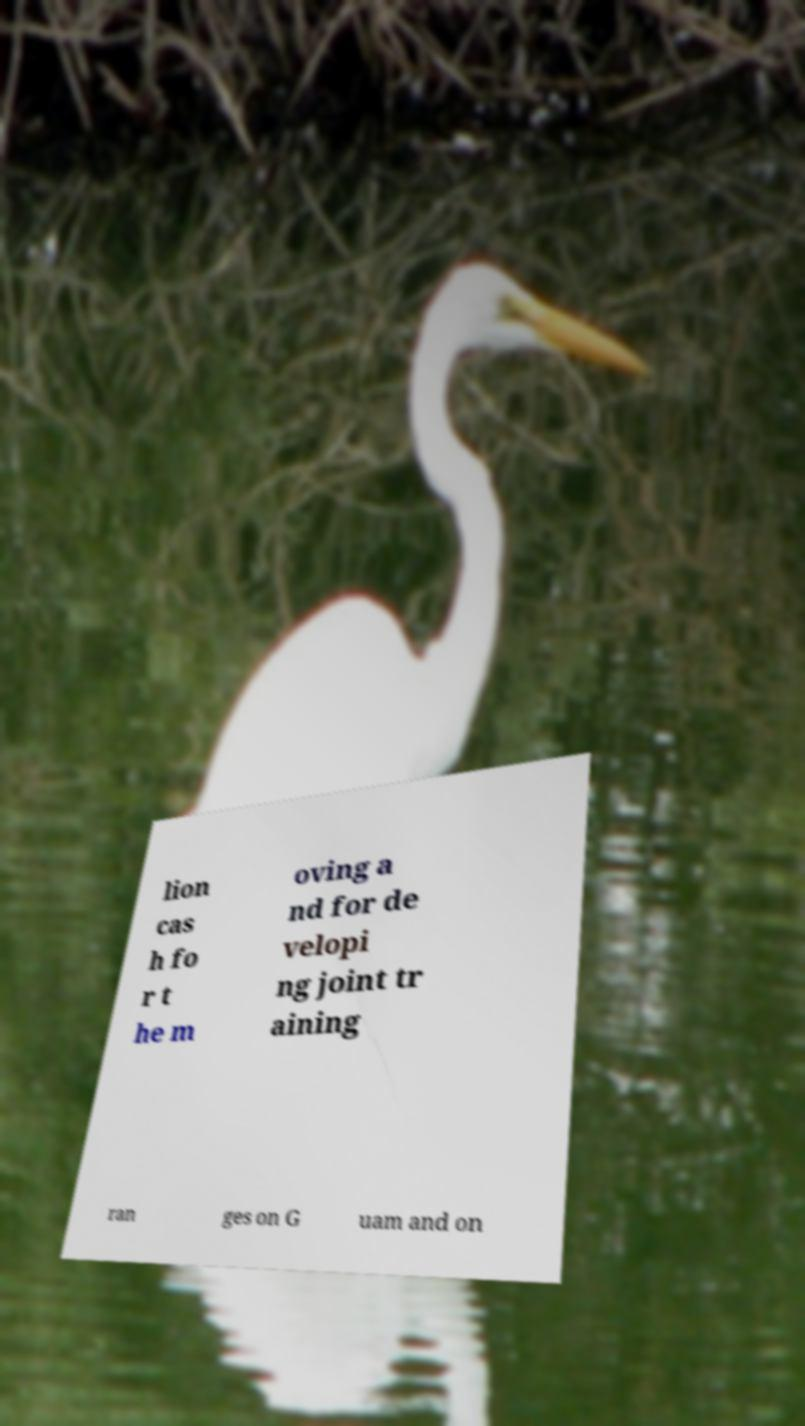I need the written content from this picture converted into text. Can you do that? lion cas h fo r t he m oving a nd for de velopi ng joint tr aining ran ges on G uam and on 